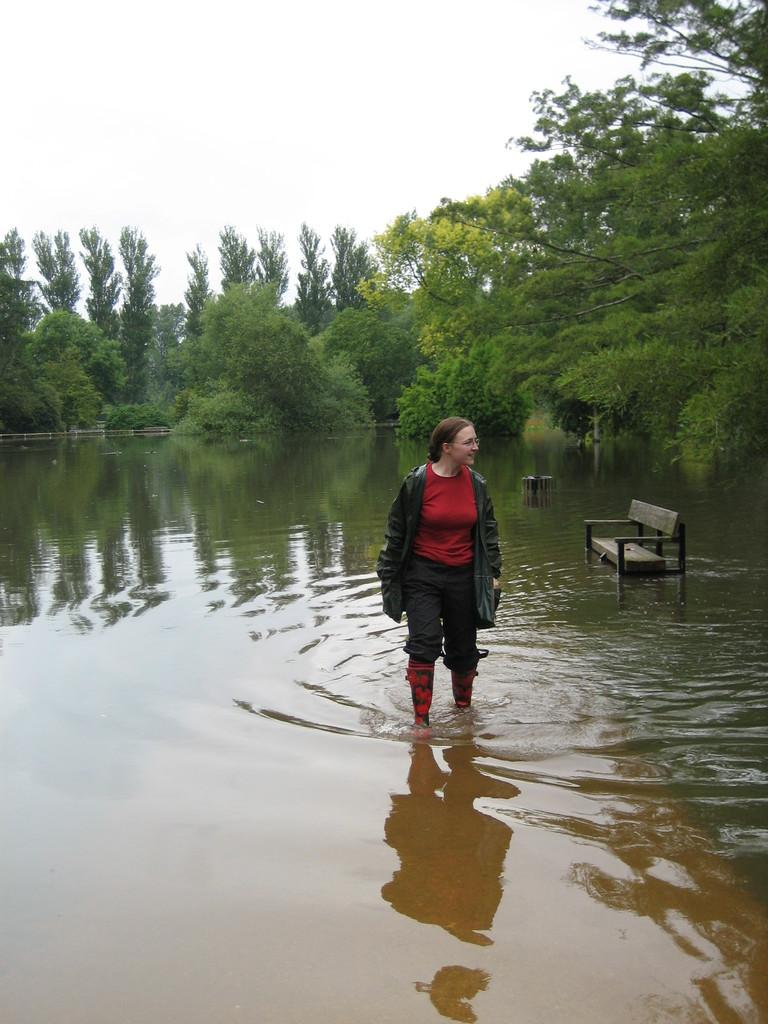What is the lady in the image doing? The lady is standing in water. What object can be seen in the image besides the lady? There is a bench in the image. What type of natural environment is visible in the background of the image? There are trees in the background of the image. What is visible in the sky in the image? The sky is visible in the background of the image. Where can the tomatoes be found in the image? There are no tomatoes present in the image. 